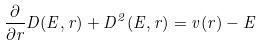<formula> <loc_0><loc_0><loc_500><loc_500>\frac { \partial } { \partial r } D ( E , r ) + D ^ { 2 } ( E , r ) = v ( r ) - E</formula> 